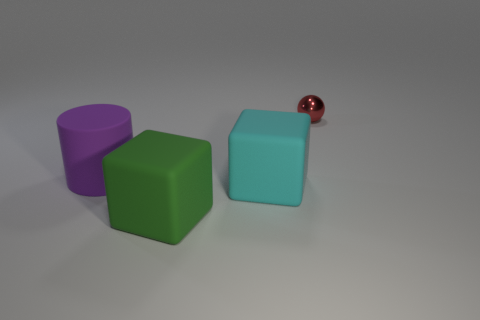Add 4 small brown shiny cubes. How many objects exist? 8 Add 2 big purple cylinders. How many big purple cylinders are left? 3 Add 2 tiny red shiny balls. How many tiny red shiny balls exist? 3 Subtract 0 cyan cylinders. How many objects are left? 4 Subtract all cylinders. How many objects are left? 3 Subtract all large cyan cubes. Subtract all purple cylinders. How many objects are left? 2 